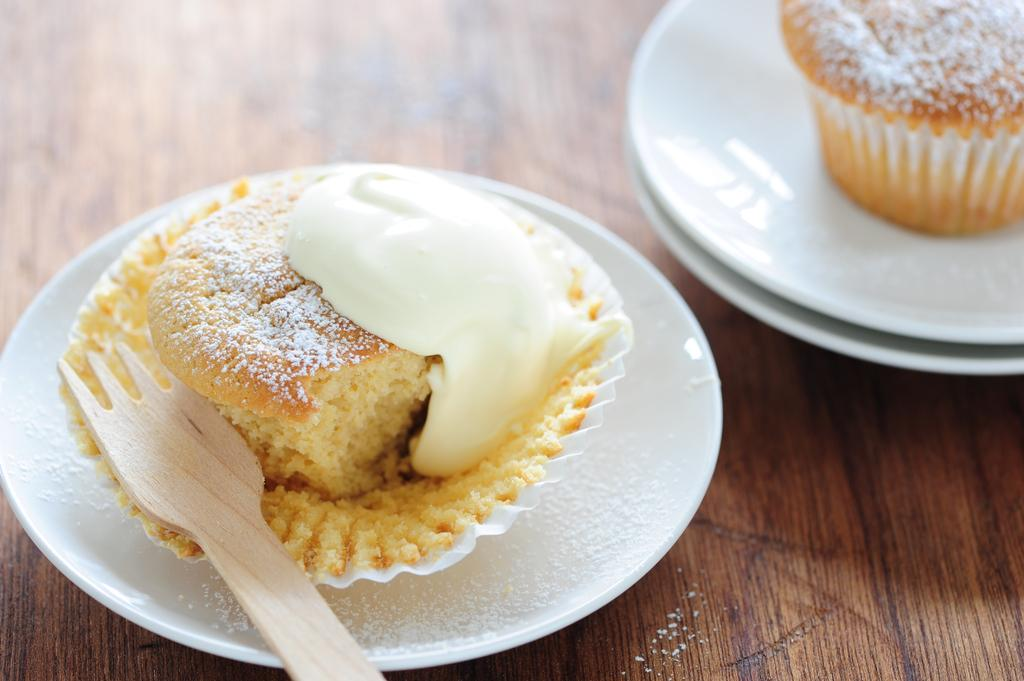What can be seen on the table in the image? There are food items in plates on the table. What utensil is visible in the image? There is a spoon visible in the image. What type of seed can be seen growing near the seashore in the image? There is no seashore or seed present in the image; it features food items on a table with a spoon. 